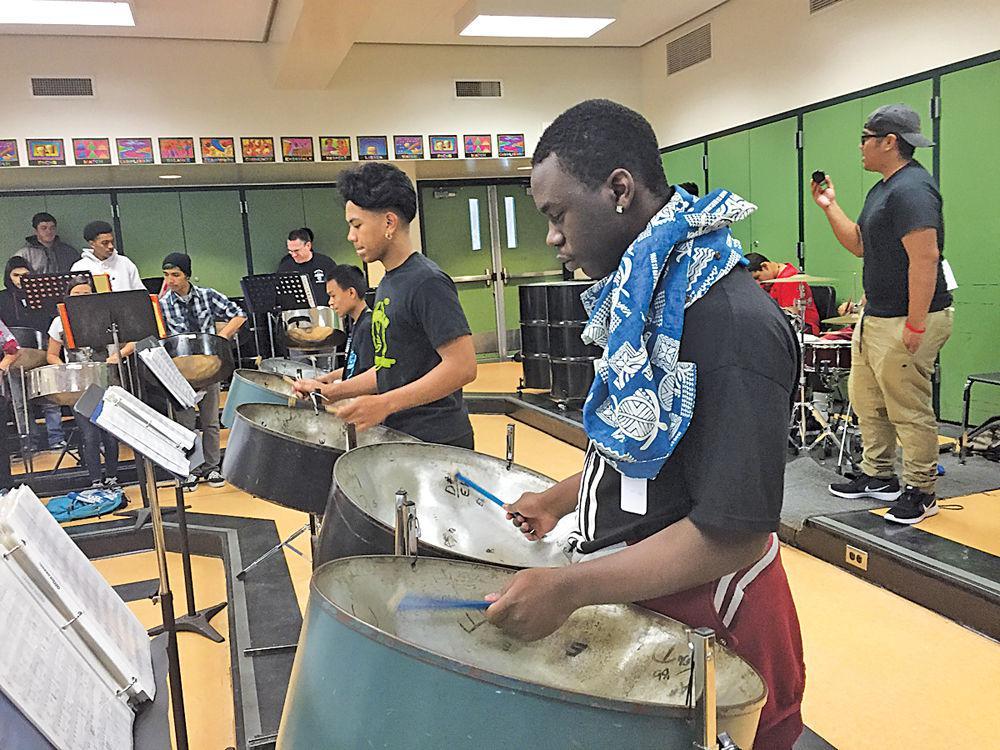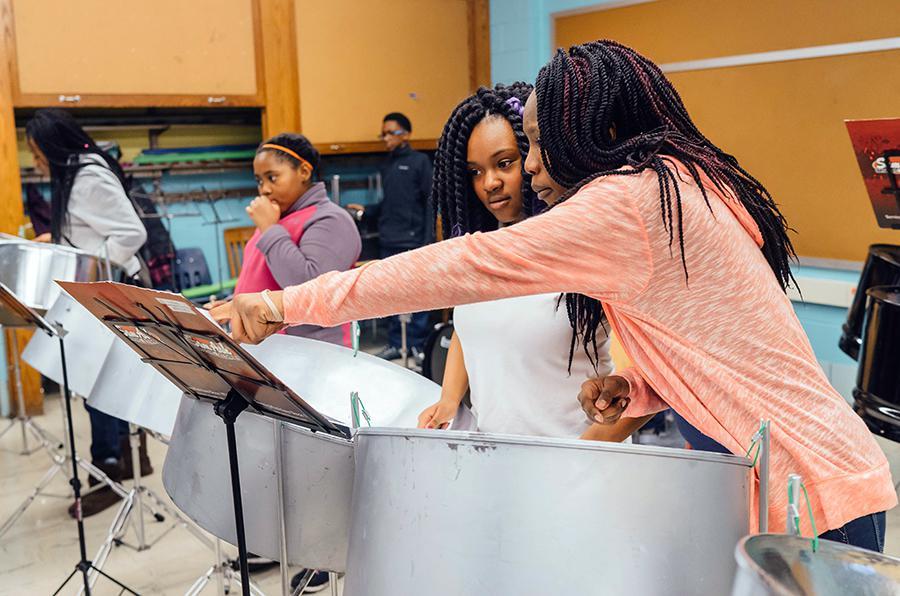The first image is the image on the left, the second image is the image on the right. Given the left and right images, does the statement "In at least one image there are at least three women of color playing a fully metal drum." hold true? Answer yes or no. Yes. The first image is the image on the left, the second image is the image on the right. Evaluate the accuracy of this statement regarding the images: "Someone is holding an instrument that is not related to drums.". Is it true? Answer yes or no. No. 